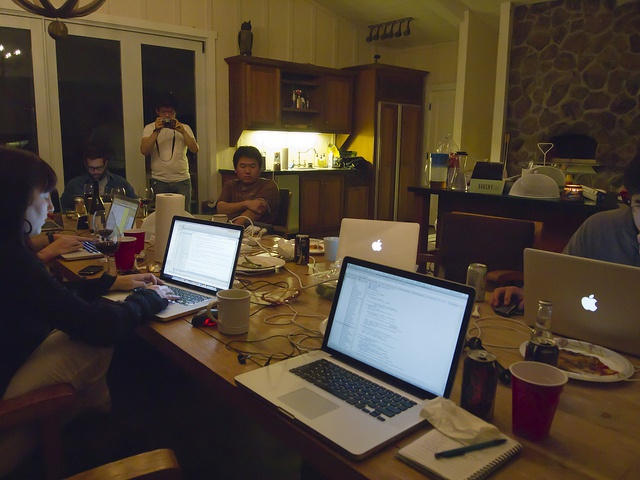Describe the objects in this image and their specific colors. I can see laptop in olive, lightblue, black, and gray tones, people in olive, black, maroon, and gray tones, laptop in olive, black, maroon, and white tones, laptop in olive, lightgray, black, darkgray, and gray tones, and chair in olive, black, and maroon tones in this image. 